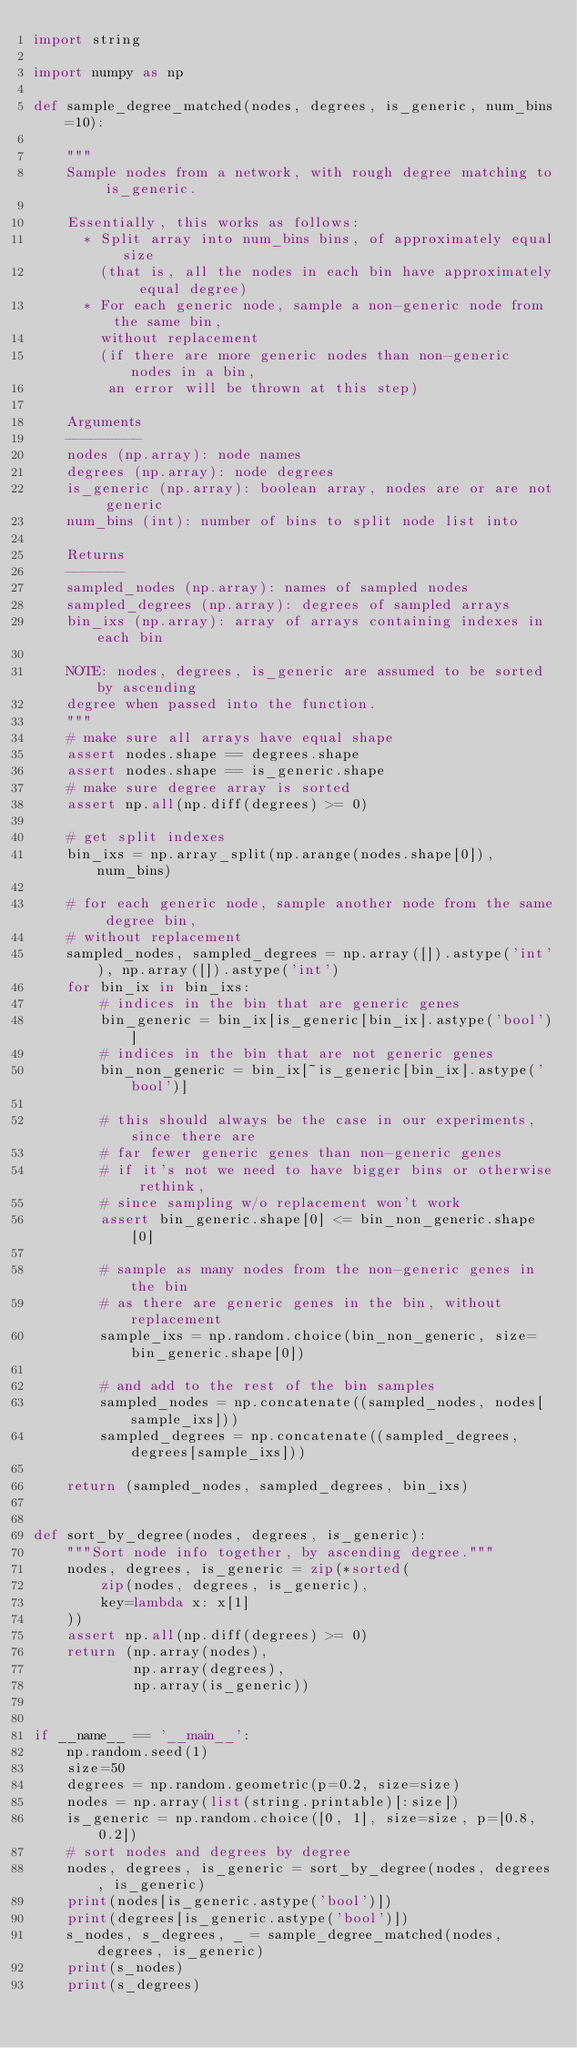Convert code to text. <code><loc_0><loc_0><loc_500><loc_500><_Python_>import string

import numpy as np

def sample_degree_matched(nodes, degrees, is_generic, num_bins=10):

    """
    Sample nodes from a network, with rough degree matching to is_generic.

    Essentially, this works as follows:
      * Split array into num_bins bins, of approximately equal size
        (that is, all the nodes in each bin have approximately equal degree)
      * For each generic node, sample a non-generic node from the same bin,
        without replacement
        (if there are more generic nodes than non-generic nodes in a bin,
         an error will be thrown at this step)

    Arguments
    ---------
    nodes (np.array): node names
    degrees (np.array): node degrees
    is_generic (np.array): boolean array, nodes are or are not generic
    num_bins (int): number of bins to split node list into

    Returns
    -------
    sampled_nodes (np.array): names of sampled nodes
    sampled_degrees (np.array): degrees of sampled arrays
    bin_ixs (np.array): array of arrays containing indexes in each bin

    NOTE: nodes, degrees, is_generic are assumed to be sorted by ascending
    degree when passed into the function.
    """
    # make sure all arrays have equal shape
    assert nodes.shape == degrees.shape
    assert nodes.shape == is_generic.shape
    # make sure degree array is sorted
    assert np.all(np.diff(degrees) >= 0)

    # get split indexes
    bin_ixs = np.array_split(np.arange(nodes.shape[0]), num_bins)

    # for each generic node, sample another node from the same degree bin,
    # without replacement
    sampled_nodes, sampled_degrees = np.array([]).astype('int'), np.array([]).astype('int')
    for bin_ix in bin_ixs:
        # indices in the bin that are generic genes
        bin_generic = bin_ix[is_generic[bin_ix].astype('bool')]
        # indices in the bin that are not generic genes
        bin_non_generic = bin_ix[~is_generic[bin_ix].astype('bool')]

        # this should always be the case in our experiments, since there are
        # far fewer generic genes than non-generic genes
        # if it's not we need to have bigger bins or otherwise rethink,
        # since sampling w/o replacement won't work
        assert bin_generic.shape[0] <= bin_non_generic.shape[0]

        # sample as many nodes from the non-generic genes in the bin
        # as there are generic genes in the bin, without replacement
        sample_ixs = np.random.choice(bin_non_generic, size=bin_generic.shape[0])

        # and add to the rest of the bin samples
        sampled_nodes = np.concatenate((sampled_nodes, nodes[sample_ixs]))
        sampled_degrees = np.concatenate((sampled_degrees, degrees[sample_ixs]))

    return (sampled_nodes, sampled_degrees, bin_ixs)


def sort_by_degree(nodes, degrees, is_generic):
    """Sort node info together, by ascending degree."""
    nodes, degrees, is_generic = zip(*sorted(
        zip(nodes, degrees, is_generic),
        key=lambda x: x[1]
    ))
    assert np.all(np.diff(degrees) >= 0)
    return (np.array(nodes),
            np.array(degrees),
            np.array(is_generic))


if __name__ == '__main__':
    np.random.seed(1)
    size=50
    degrees = np.random.geometric(p=0.2, size=size)
    nodes = np.array(list(string.printable)[:size])
    is_generic = np.random.choice([0, 1], size=size, p=[0.8, 0.2])
    # sort nodes and degrees by degree
    nodes, degrees, is_generic = sort_by_degree(nodes, degrees, is_generic)
    print(nodes[is_generic.astype('bool')])
    print(degrees[is_generic.astype('bool')])
    s_nodes, s_degrees, _ = sample_degree_matched(nodes, degrees, is_generic)
    print(s_nodes)
    print(s_degrees)

</code> 